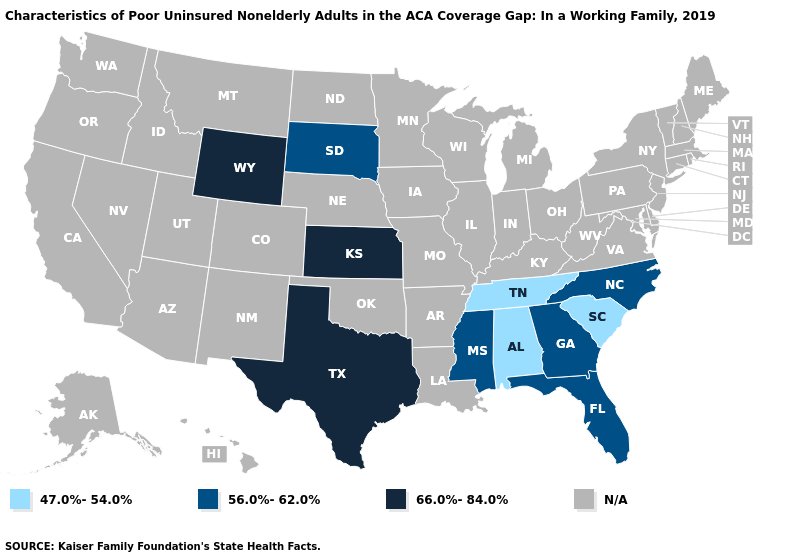What is the value of Illinois?
Write a very short answer. N/A. Name the states that have a value in the range N/A?
Answer briefly. Alaska, Arizona, Arkansas, California, Colorado, Connecticut, Delaware, Hawaii, Idaho, Illinois, Indiana, Iowa, Kentucky, Louisiana, Maine, Maryland, Massachusetts, Michigan, Minnesota, Missouri, Montana, Nebraska, Nevada, New Hampshire, New Jersey, New Mexico, New York, North Dakota, Ohio, Oklahoma, Oregon, Pennsylvania, Rhode Island, Utah, Vermont, Virginia, Washington, West Virginia, Wisconsin. What is the lowest value in the USA?
Write a very short answer. 47.0%-54.0%. What is the value of Tennessee?
Short answer required. 47.0%-54.0%. Does Alabama have the lowest value in the USA?
Quick response, please. Yes. Does North Carolina have the highest value in the USA?
Keep it brief. No. Does South Carolina have the highest value in the South?
Keep it brief. No. Among the states that border South Dakota , which have the lowest value?
Be succinct. Wyoming. Name the states that have a value in the range 47.0%-54.0%?
Quick response, please. Alabama, South Carolina, Tennessee. 